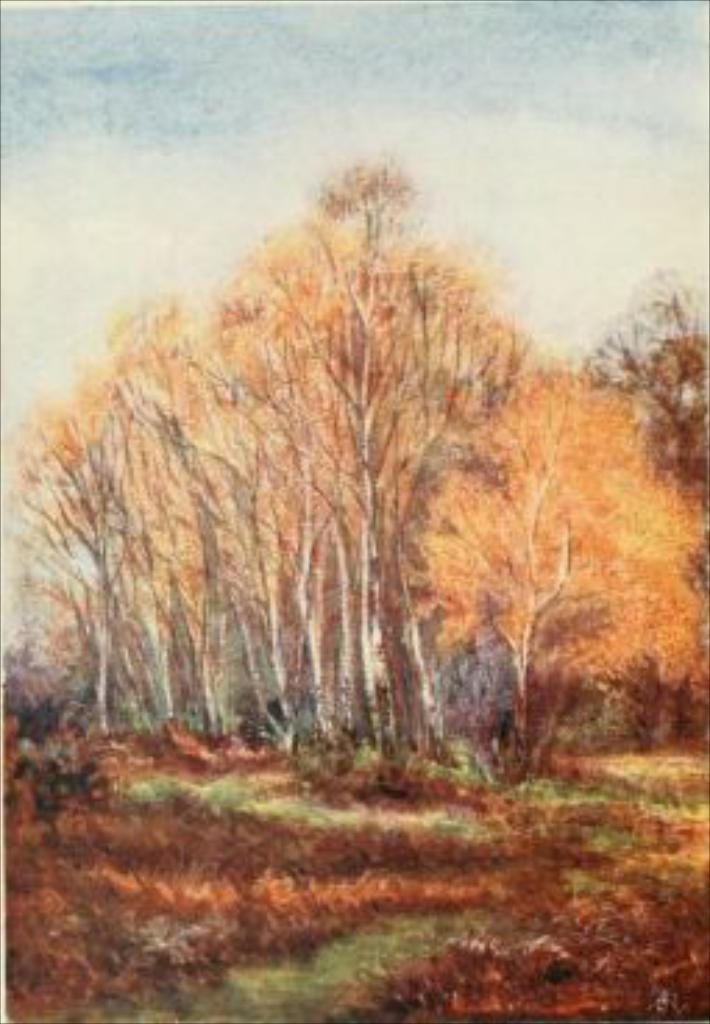What type of artwork is shown in the image? The image is a painting. What is the subject matter of the painting? The painting depicts a forest. What type of vegetation can be seen in the painting? There is grass in the painting. What are the characteristics of the trees in the painting? There are tall trees in the painting. What type of treatment is being administered to the donkey in the painting? There is no donkey present in the painting; it depicts a forest with grass and tall trees. 